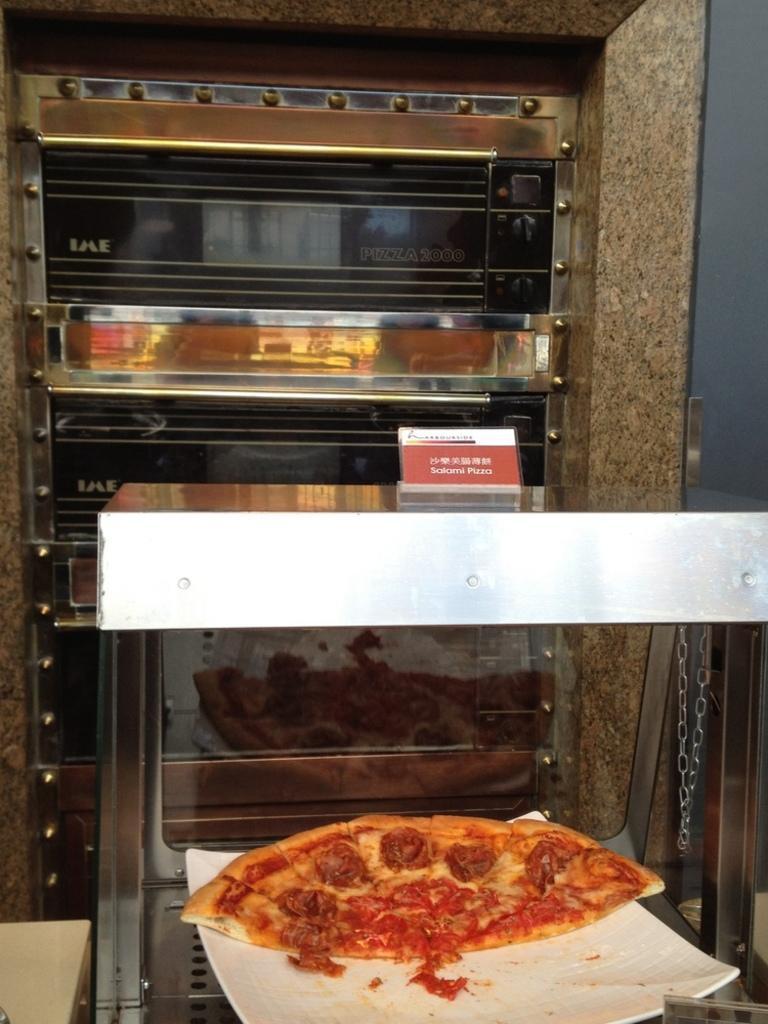How would you summarize this image in a sentence or two? In the foreground I can see a pizza in a plate. In the background I can see ovens and a wall. This image is taken may be in a hall. 